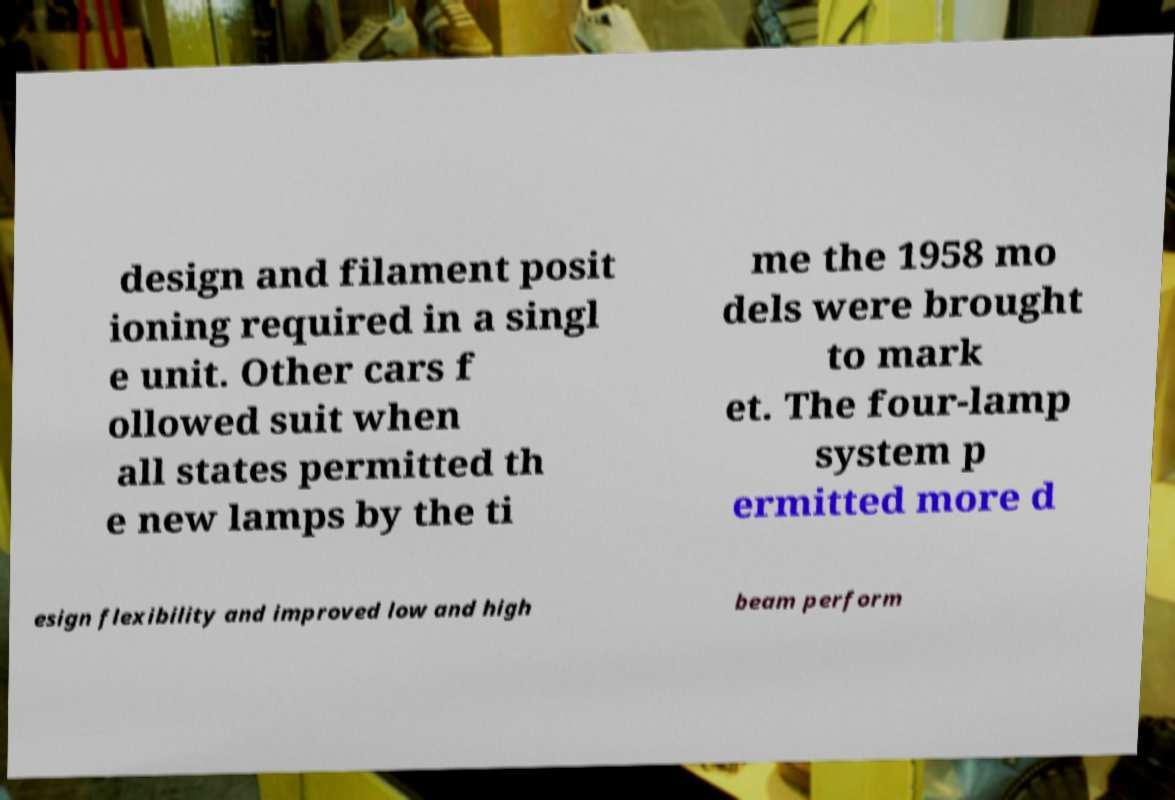There's text embedded in this image that I need extracted. Can you transcribe it verbatim? design and filament posit ioning required in a singl e unit. Other cars f ollowed suit when all states permitted th e new lamps by the ti me the 1958 mo dels were brought to mark et. The four-lamp system p ermitted more d esign flexibility and improved low and high beam perform 